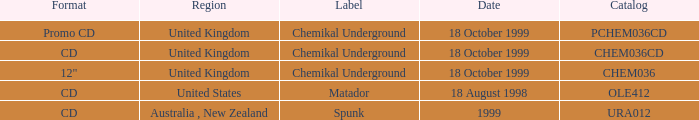What label is associated with the United Kingdom and the chem036 catalog? Chemikal Underground. 